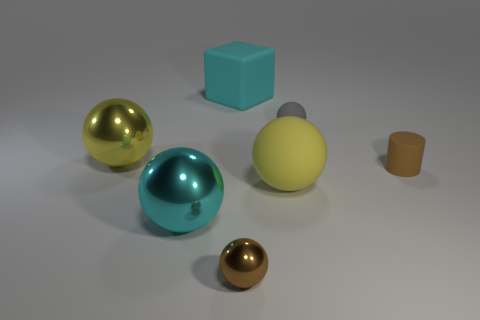Is there anything else that is the same size as the cyan shiny object?
Keep it short and to the point. Yes. There is a large rubber cube; what number of big matte things are in front of it?
Your answer should be compact. 1. Is the number of tiny brown objects on the left side of the brown metal thing the same as the number of small brown cylinders?
Your answer should be compact. No. What number of things are big yellow cylinders or small gray spheres?
Offer a very short reply. 1. Is there anything else that is the same shape as the cyan metal object?
Your response must be concise. Yes. What is the shape of the cyan object in front of the tiny brown thing to the right of the tiny gray matte ball?
Provide a short and direct response. Sphere. The yellow thing that is the same material as the small gray sphere is what shape?
Provide a succinct answer. Sphere. What is the size of the rubber object that is in front of the brown object that is on the right side of the tiny metallic sphere?
Your answer should be very brief. Large. The yellow matte thing is what shape?
Offer a terse response. Sphere. What number of large objects are blocks or yellow rubber balls?
Ensure brevity in your answer.  2. 